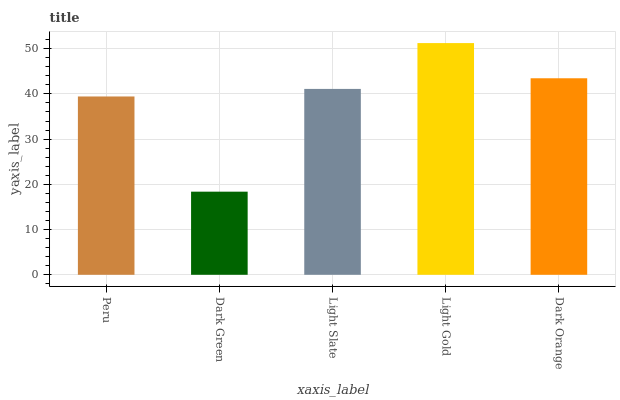Is Dark Green the minimum?
Answer yes or no. Yes. Is Light Gold the maximum?
Answer yes or no. Yes. Is Light Slate the minimum?
Answer yes or no. No. Is Light Slate the maximum?
Answer yes or no. No. Is Light Slate greater than Dark Green?
Answer yes or no. Yes. Is Dark Green less than Light Slate?
Answer yes or no. Yes. Is Dark Green greater than Light Slate?
Answer yes or no. No. Is Light Slate less than Dark Green?
Answer yes or no. No. Is Light Slate the high median?
Answer yes or no. Yes. Is Light Slate the low median?
Answer yes or no. Yes. Is Light Gold the high median?
Answer yes or no. No. Is Peru the low median?
Answer yes or no. No. 